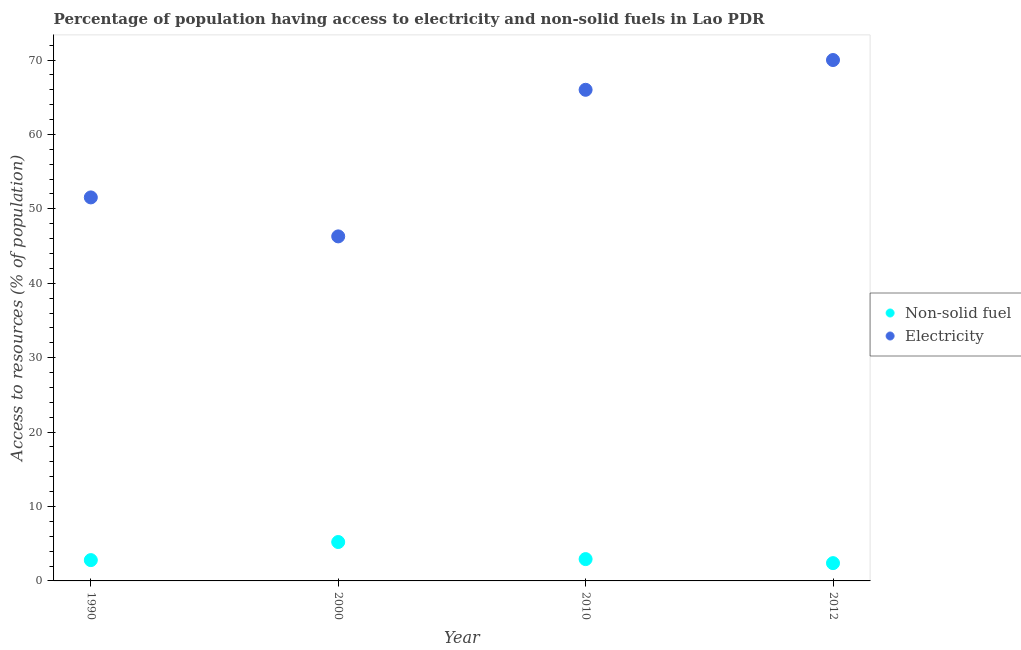Across all years, what is the maximum percentage of population having access to electricity?
Offer a terse response. 70. Across all years, what is the minimum percentage of population having access to non-solid fuel?
Make the answer very short. 2.39. In which year was the percentage of population having access to electricity minimum?
Keep it short and to the point. 2000. What is the total percentage of population having access to non-solid fuel in the graph?
Offer a terse response. 13.35. What is the difference between the percentage of population having access to electricity in 2000 and that in 2012?
Your answer should be very brief. -23.7. What is the difference between the percentage of population having access to non-solid fuel in 2010 and the percentage of population having access to electricity in 1990?
Provide a short and direct response. -48.61. What is the average percentage of population having access to non-solid fuel per year?
Make the answer very short. 3.34. In the year 2010, what is the difference between the percentage of population having access to non-solid fuel and percentage of population having access to electricity?
Give a very brief answer. -63.07. In how many years, is the percentage of population having access to electricity greater than 46 %?
Offer a very short reply. 4. What is the ratio of the percentage of population having access to electricity in 2000 to that in 2012?
Your answer should be very brief. 0.66. What is the difference between the highest and the second highest percentage of population having access to non-solid fuel?
Your answer should be very brief. 2.3. What is the difference between the highest and the lowest percentage of population having access to electricity?
Your response must be concise. 23.7. In how many years, is the percentage of population having access to non-solid fuel greater than the average percentage of population having access to non-solid fuel taken over all years?
Offer a terse response. 1. Is the percentage of population having access to non-solid fuel strictly greater than the percentage of population having access to electricity over the years?
Your response must be concise. No. How many years are there in the graph?
Provide a succinct answer. 4. What is the difference between two consecutive major ticks on the Y-axis?
Provide a succinct answer. 10. Are the values on the major ticks of Y-axis written in scientific E-notation?
Make the answer very short. No. Does the graph contain any zero values?
Provide a succinct answer. No. Where does the legend appear in the graph?
Make the answer very short. Center right. What is the title of the graph?
Ensure brevity in your answer.  Percentage of population having access to electricity and non-solid fuels in Lao PDR. Does "Crop" appear as one of the legend labels in the graph?
Keep it short and to the point. No. What is the label or title of the Y-axis?
Ensure brevity in your answer.  Access to resources (% of population). What is the Access to resources (% of population) in Non-solid fuel in 1990?
Give a very brief answer. 2.8. What is the Access to resources (% of population) of Electricity in 1990?
Ensure brevity in your answer.  51.54. What is the Access to resources (% of population) in Non-solid fuel in 2000?
Provide a succinct answer. 5.23. What is the Access to resources (% of population) in Electricity in 2000?
Your answer should be very brief. 46.3. What is the Access to resources (% of population) of Non-solid fuel in 2010?
Offer a terse response. 2.93. What is the Access to resources (% of population) in Non-solid fuel in 2012?
Keep it short and to the point. 2.39. Across all years, what is the maximum Access to resources (% of population) of Non-solid fuel?
Keep it short and to the point. 5.23. Across all years, what is the maximum Access to resources (% of population) of Electricity?
Provide a succinct answer. 70. Across all years, what is the minimum Access to resources (% of population) of Non-solid fuel?
Provide a succinct answer. 2.39. Across all years, what is the minimum Access to resources (% of population) of Electricity?
Give a very brief answer. 46.3. What is the total Access to resources (% of population) of Non-solid fuel in the graph?
Keep it short and to the point. 13.35. What is the total Access to resources (% of population) in Electricity in the graph?
Your answer should be very brief. 233.84. What is the difference between the Access to resources (% of population) in Non-solid fuel in 1990 and that in 2000?
Provide a short and direct response. -2.43. What is the difference between the Access to resources (% of population) of Electricity in 1990 and that in 2000?
Offer a very short reply. 5.24. What is the difference between the Access to resources (% of population) in Non-solid fuel in 1990 and that in 2010?
Make the answer very short. -0.14. What is the difference between the Access to resources (% of population) of Electricity in 1990 and that in 2010?
Give a very brief answer. -14.46. What is the difference between the Access to resources (% of population) in Non-solid fuel in 1990 and that in 2012?
Your answer should be compact. 0.41. What is the difference between the Access to resources (% of population) in Electricity in 1990 and that in 2012?
Provide a short and direct response. -18.46. What is the difference between the Access to resources (% of population) of Non-solid fuel in 2000 and that in 2010?
Provide a short and direct response. 2.3. What is the difference between the Access to resources (% of population) of Electricity in 2000 and that in 2010?
Provide a short and direct response. -19.7. What is the difference between the Access to resources (% of population) in Non-solid fuel in 2000 and that in 2012?
Provide a succinct answer. 2.84. What is the difference between the Access to resources (% of population) of Electricity in 2000 and that in 2012?
Provide a succinct answer. -23.7. What is the difference between the Access to resources (% of population) in Non-solid fuel in 2010 and that in 2012?
Your answer should be compact. 0.54. What is the difference between the Access to resources (% of population) of Non-solid fuel in 1990 and the Access to resources (% of population) of Electricity in 2000?
Offer a terse response. -43.5. What is the difference between the Access to resources (% of population) in Non-solid fuel in 1990 and the Access to resources (% of population) in Electricity in 2010?
Provide a short and direct response. -63.2. What is the difference between the Access to resources (% of population) of Non-solid fuel in 1990 and the Access to resources (% of population) of Electricity in 2012?
Your answer should be very brief. -67.2. What is the difference between the Access to resources (% of population) of Non-solid fuel in 2000 and the Access to resources (% of population) of Electricity in 2010?
Keep it short and to the point. -60.77. What is the difference between the Access to resources (% of population) of Non-solid fuel in 2000 and the Access to resources (% of population) of Electricity in 2012?
Your answer should be very brief. -64.77. What is the difference between the Access to resources (% of population) in Non-solid fuel in 2010 and the Access to resources (% of population) in Electricity in 2012?
Keep it short and to the point. -67.07. What is the average Access to resources (% of population) of Non-solid fuel per year?
Offer a terse response. 3.34. What is the average Access to resources (% of population) in Electricity per year?
Make the answer very short. 58.46. In the year 1990, what is the difference between the Access to resources (% of population) in Non-solid fuel and Access to resources (% of population) in Electricity?
Your answer should be very brief. -48.74. In the year 2000, what is the difference between the Access to resources (% of population) in Non-solid fuel and Access to resources (% of population) in Electricity?
Keep it short and to the point. -41.07. In the year 2010, what is the difference between the Access to resources (% of population) in Non-solid fuel and Access to resources (% of population) in Electricity?
Your response must be concise. -63.07. In the year 2012, what is the difference between the Access to resources (% of population) in Non-solid fuel and Access to resources (% of population) in Electricity?
Keep it short and to the point. -67.61. What is the ratio of the Access to resources (% of population) in Non-solid fuel in 1990 to that in 2000?
Keep it short and to the point. 0.54. What is the ratio of the Access to resources (% of population) of Electricity in 1990 to that in 2000?
Offer a terse response. 1.11. What is the ratio of the Access to resources (% of population) of Non-solid fuel in 1990 to that in 2010?
Provide a succinct answer. 0.95. What is the ratio of the Access to resources (% of population) of Electricity in 1990 to that in 2010?
Ensure brevity in your answer.  0.78. What is the ratio of the Access to resources (% of population) in Non-solid fuel in 1990 to that in 2012?
Your response must be concise. 1.17. What is the ratio of the Access to resources (% of population) of Electricity in 1990 to that in 2012?
Your answer should be compact. 0.74. What is the ratio of the Access to resources (% of population) in Non-solid fuel in 2000 to that in 2010?
Your response must be concise. 1.78. What is the ratio of the Access to resources (% of population) in Electricity in 2000 to that in 2010?
Keep it short and to the point. 0.7. What is the ratio of the Access to resources (% of population) in Non-solid fuel in 2000 to that in 2012?
Offer a very short reply. 2.19. What is the ratio of the Access to resources (% of population) in Electricity in 2000 to that in 2012?
Your answer should be compact. 0.66. What is the ratio of the Access to resources (% of population) in Non-solid fuel in 2010 to that in 2012?
Keep it short and to the point. 1.23. What is the ratio of the Access to resources (% of population) of Electricity in 2010 to that in 2012?
Ensure brevity in your answer.  0.94. What is the difference between the highest and the second highest Access to resources (% of population) in Non-solid fuel?
Ensure brevity in your answer.  2.3. What is the difference between the highest and the lowest Access to resources (% of population) of Non-solid fuel?
Offer a terse response. 2.84. What is the difference between the highest and the lowest Access to resources (% of population) in Electricity?
Provide a succinct answer. 23.7. 